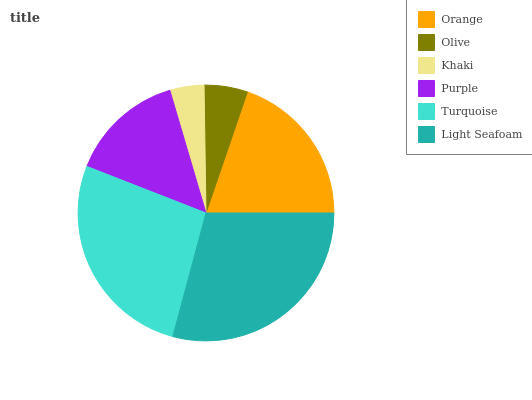Is Khaki the minimum?
Answer yes or no. Yes. Is Light Seafoam the maximum?
Answer yes or no. Yes. Is Olive the minimum?
Answer yes or no. No. Is Olive the maximum?
Answer yes or no. No. Is Orange greater than Olive?
Answer yes or no. Yes. Is Olive less than Orange?
Answer yes or no. Yes. Is Olive greater than Orange?
Answer yes or no. No. Is Orange less than Olive?
Answer yes or no. No. Is Orange the high median?
Answer yes or no. Yes. Is Purple the low median?
Answer yes or no. Yes. Is Purple the high median?
Answer yes or no. No. Is Light Seafoam the low median?
Answer yes or no. No. 